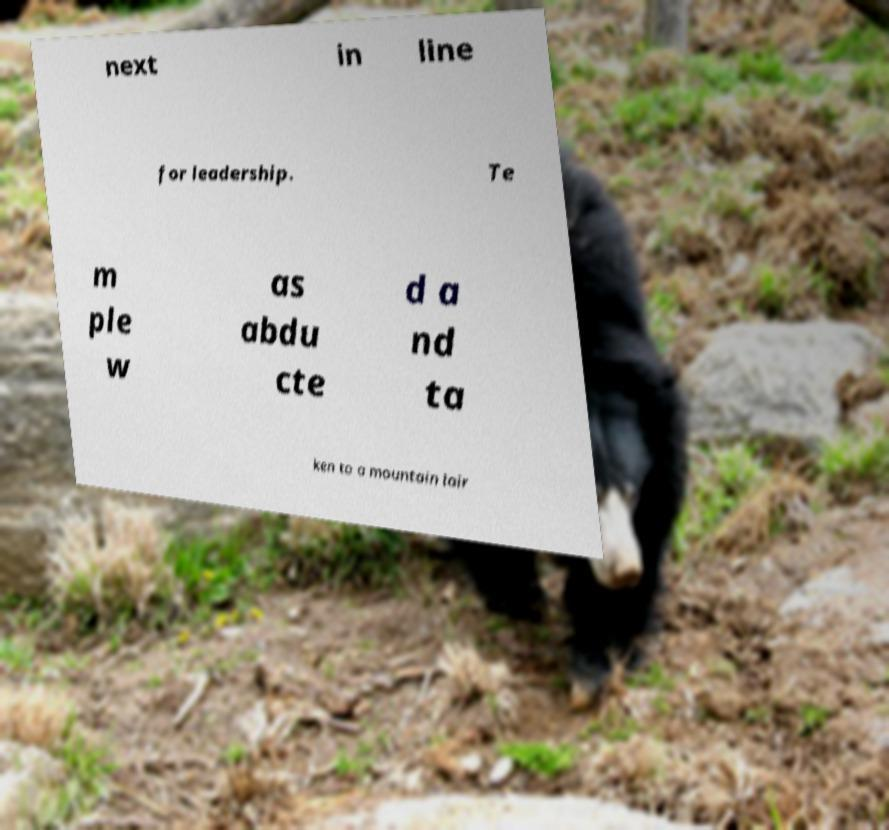What messages or text are displayed in this image? I need them in a readable, typed format. next in line for leadership. Te m ple w as abdu cte d a nd ta ken to a mountain lair 